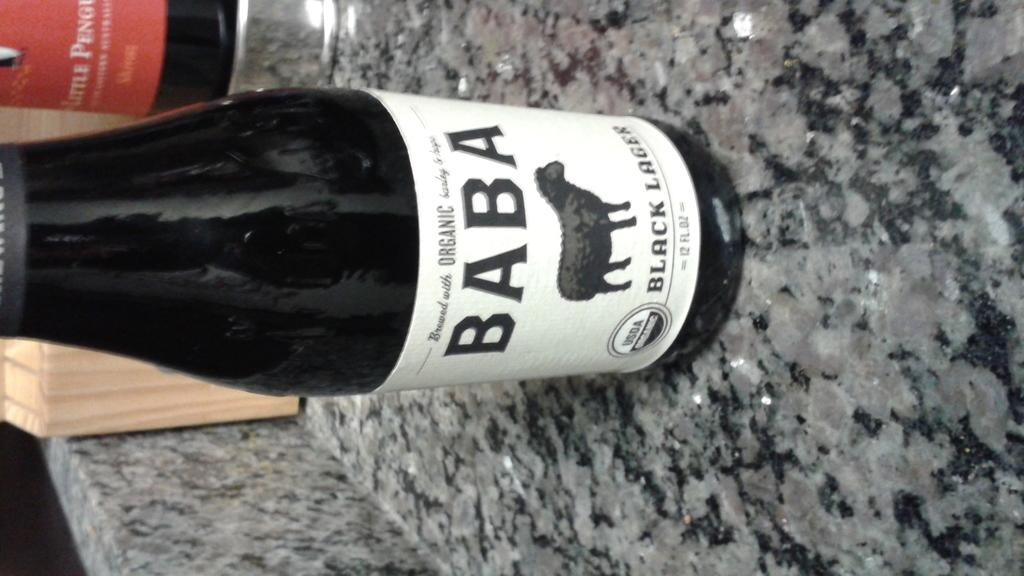Provide a one-sentence caption for the provided image. A bottle of Baba Black beer on a granite counter. 